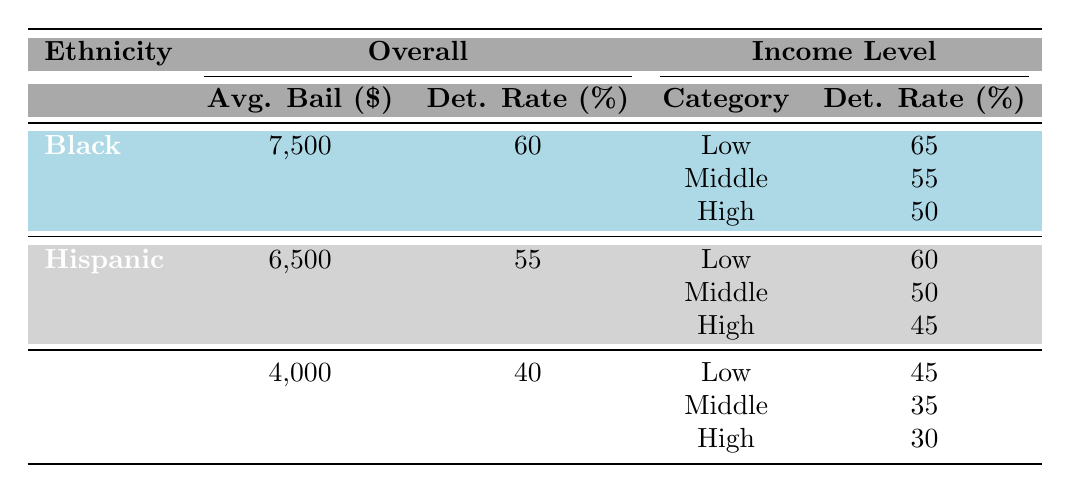What is the average bail amount for Black individuals? The table shows that the average bail amount for Black individuals is listed directly in the "Overall" column under the "Black" row, which states 7500.
Answer: 7500 What is the pretrial detention rate for Hispanic individuals with a middle income level? The middle income level row for Hispanic individuals shows a pretrial detention rate of 50.
Answer: 50 Is the average bail amount for low-income Hispanic individuals higher or lower than that for low-income Black individuals? The average bail amount for low-income Hispanic individuals is 8000, while for low-income Black individuals it is 9000. Hence, low-income Hispanic bail is lower.
Answer: Lower What is the difference in pretrial detention rates between White individuals and Black individuals? The pretrial detention rate for White individuals is 40, and for Black individuals, it is 60. The difference is 60 - 40 = 20.
Answer: 20 Do Hispanic individuals have a lower average bail amount compared to White individuals? The average bail amount for Hispanic individuals is 6500, and for White individuals, it is 4000. Since 6500 is greater than 4000, the statement is false.
Answer: No If you compare the average bail amounts of high-income individuals across all ethnicities, who has the lowest amount? Checking the table, high-income Black individuals have an average bail amount of 3000, Hispanic individuals have 2500, and White individuals have 2000. White individuals have the lowest with 2000.
Answer: White individuals What is the average pretrial detention rate for individuals with a high income level? For Black individuals, the high income pretrial detention rate is 50; for Hispanic, it's 45; and for White, it's 30. The average is (50 + 45 + 30) / 3 = 41.67, which rounds to 42.
Answer: 42 Which group has the highest overall pretrial detention rate? The table shows pretrial detention rates of 60 for Black, 55 for Hispanic, and 40 for White individuals. Black individuals have the highest rate at 60.
Answer: Black individuals What is the average bail amount for middle-income White individuals? The average bail amount for middle-income White individuals is specified directly in the table as 3500.
Answer: 3500 